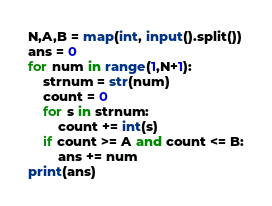<code> <loc_0><loc_0><loc_500><loc_500><_Python_>N,A,B = map(int, input().split())
ans = 0
for num in range(1,N+1):
    strnum = str(num)
    count = 0
    for s in strnum:
        count += int(s)
    if count >= A and count <= B:
        ans += num
print(ans)</code> 